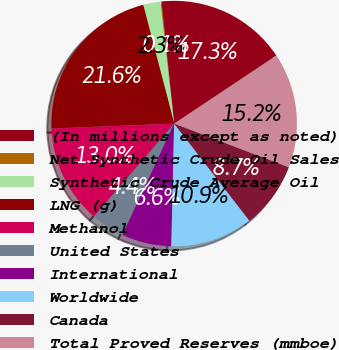Convert chart to OTSL. <chart><loc_0><loc_0><loc_500><loc_500><pie_chart><fcel>(In millions except as noted)<fcel>Net Synthetic Crude Oil Sales<fcel>Synthetic Crude Average Oil<fcel>LNG (g)<fcel>Methanol<fcel>United States<fcel>International<fcel>Worldwide<fcel>Canada<fcel>Total Proved Reserves (mmboe)<nl><fcel>17.29%<fcel>0.13%<fcel>2.28%<fcel>21.59%<fcel>13.0%<fcel>4.42%<fcel>6.57%<fcel>10.86%<fcel>8.71%<fcel>15.15%<nl></chart> 